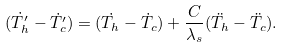Convert formula to latex. <formula><loc_0><loc_0><loc_500><loc_500>( \dot { T _ { h } ^ { \prime } } - \dot { T _ { c } ^ { \prime } } ) = ( \dot { T _ { h } } - \dot { T _ { c } } ) + \frac { C } { \lambda _ { s } } ( \ddot { T _ { h } } - \ddot { T _ { c } } ) .</formula> 